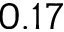Convert formula to latex. <formula><loc_0><loc_0><loc_500><loc_500>0 . 1 7</formula> 